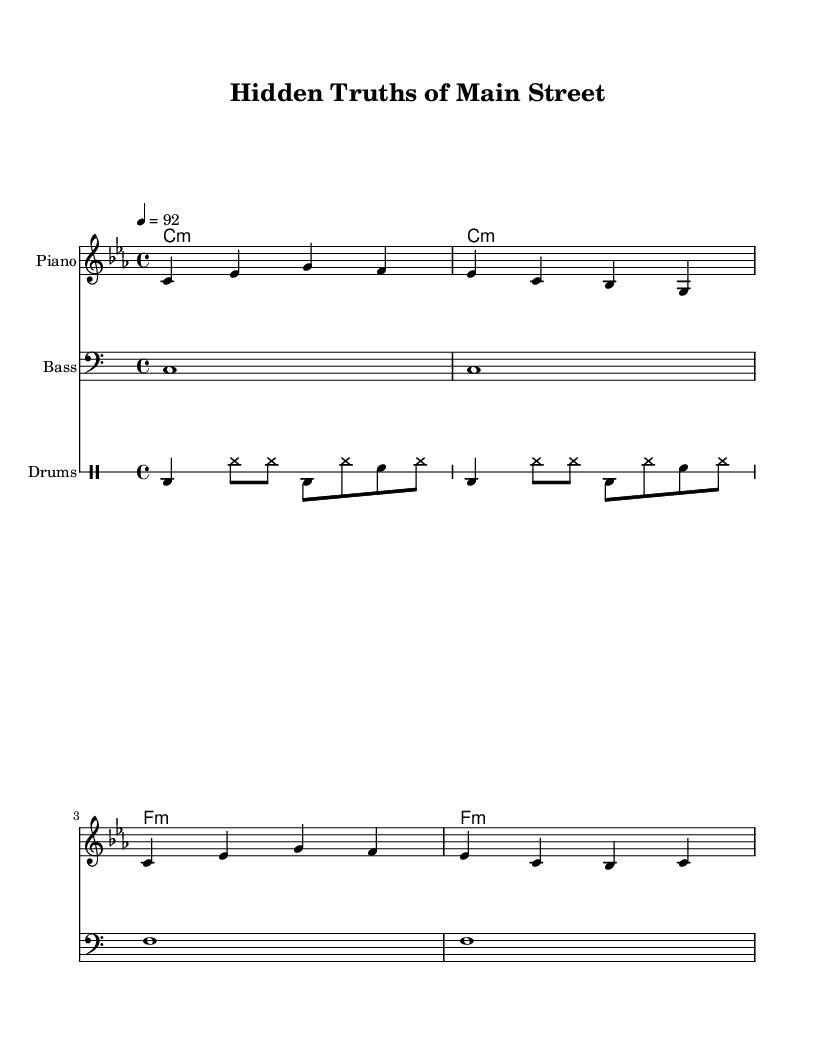What is the key signature of this music? The key signature is indicated at the beginning of the score, and it shows that there are three flats, suggesting the key of C minor.
Answer: C minor What is the time signature of this piece? The time signature is located at the beginning of the score before the melody line, indicating that there are 4 beats per measure.
Answer: 4/4 What is the tempo marking in the sheet music? The tempo marking is found at the beginning of the score and indicates the speed of the piece, which is set at 92 beats per minute.
Answer: 92 How many measures are present in the melody? By counting the individual segments of the melody notation, it is clear that there are four distinct measures indicated.
Answer: 4 Which instruments are featured in this composition? The instruments can be identified by their labeled staves in the score: Piano, Bass, and Drums.
Answer: Piano, Bass, Drums What is the main theme expressed in the lyrics? The lyrics reflect a narrative about uncovering secrets and hidden truths that are buried in the area, particularly referencing Main Street.
Answer: Secrets 